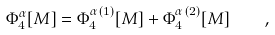Convert formula to latex. <formula><loc_0><loc_0><loc_500><loc_500>\Phi ^ { \alpha } _ { 4 } [ { M } ] = \Phi ^ { \alpha \, ( 1 ) } _ { 4 } [ { M } ] + \Phi ^ { \alpha \, ( 2 ) } _ { 4 } [ { M } ] \quad ,</formula> 